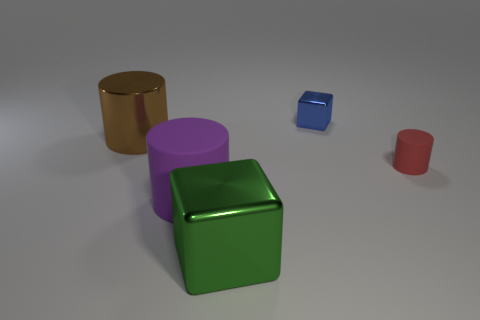Subtract all big purple rubber cylinders. How many cylinders are left? 2 Add 3 red rubber cylinders. How many objects exist? 8 Subtract all cubes. How many objects are left? 3 Subtract all green cylinders. Subtract all red balls. How many cylinders are left? 3 Subtract all small cylinders. Subtract all big brown shiny things. How many objects are left? 3 Add 5 red rubber objects. How many red rubber objects are left? 6 Add 1 brown shiny cylinders. How many brown shiny cylinders exist? 2 Subtract 0 red cubes. How many objects are left? 5 